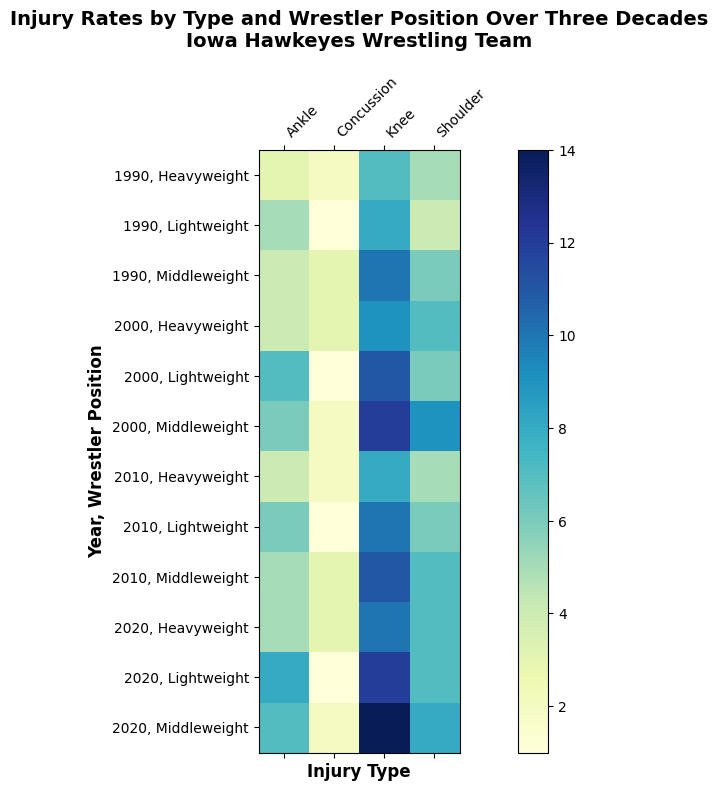How did the rate of knee injuries in the heavyweight position change over the decades? To find the rate of knee injuries in the heavyweight position, look at the corresponding cells for 1990, 2000, 2010, and 2020. The values are 7, 9, 8, and 10 respectively. The trend shows an initial increase from 1990 to 2000, then a slight decline in 2010, and an increase again in 2020.
Answer: The rate increased initially, slightly declined, then increased again Which wrestler position had the highest concussion rate in 2010? To determine this, look at the columns for concussions in 2010 and compare the values for heavyweight, middleweight, and lightweight positions. The values are 2 for heavyweight, 3 for middleweight, and 1 for lightweight.
Answer: Middleweight What is the total number of shoulder injuries in 2020 across all positions? To find the total, sum the shoulder injury counts for heavyweight, middleweight, and lightweight positions in 2020. The values are 7, 8, and 7 respectively. 7 + 8 + 7 = 22
Answer: 22 Compare the number of ankle injuries in middleweight in 1990 and 2020. Locate the ankle injury counts for middleweight in 1990 and 2020. In 1990, the count is 4, and in 2020, the count is 7. Compare the values to see that 7 is greater than 4.
Answer: 2020 has more What is the average number of knee injuries in the lightweight position over the decades? For this, sum the knee injuries in the lightweight position over the years 1990, 2000, 2010, and 2020, then divide by the number of years (4). The values are 8, 11, 10, and 12 respectively. (8 + 11 + 10 + 12) / 4 = 41 / 4 = 10.25
Answer: 10.25 Which decade had the highest rate of ankle injuries for the lightweight position? Look at the ankle injury counts for lightweight across all decades: 1990 (5), 2000 (7), 2010 (6), and 2020 (8). The highest value is in 2020.
Answer: 2020 Did the shoulder injury rate for the middleweight position increase or decrease from 2000 to 2010? Compare the shoulder injury counts for middleweight in 2000 and 2010. The values are 9 in 2000 and 7 in 2010. 7 is less than 9 indicating a decrease.
Answer: Decrease Which injury type saw the least change in rates for heavyweights from 1990 to 2020? Look at all injury types (knee, shoulder, ankle, concussion) for heavyweights from 1990 to 2020. Calculate the differences: knee (10-7=3), shoulder (7-5=2), ankle (5-3=2), concussion (3-2=1). Concussion saw the least change with only a 1-unit difference.
Answer: Concussion How many total injuries were there in the middleweight position in 2010? Sum all the injuries (knee, shoulder, ankle, concussion) for middleweight in 2010. The counts are 11, 7, 5, and 3 respectively. 11 + 7 + 5 + 3 = 26
Answer: 26 